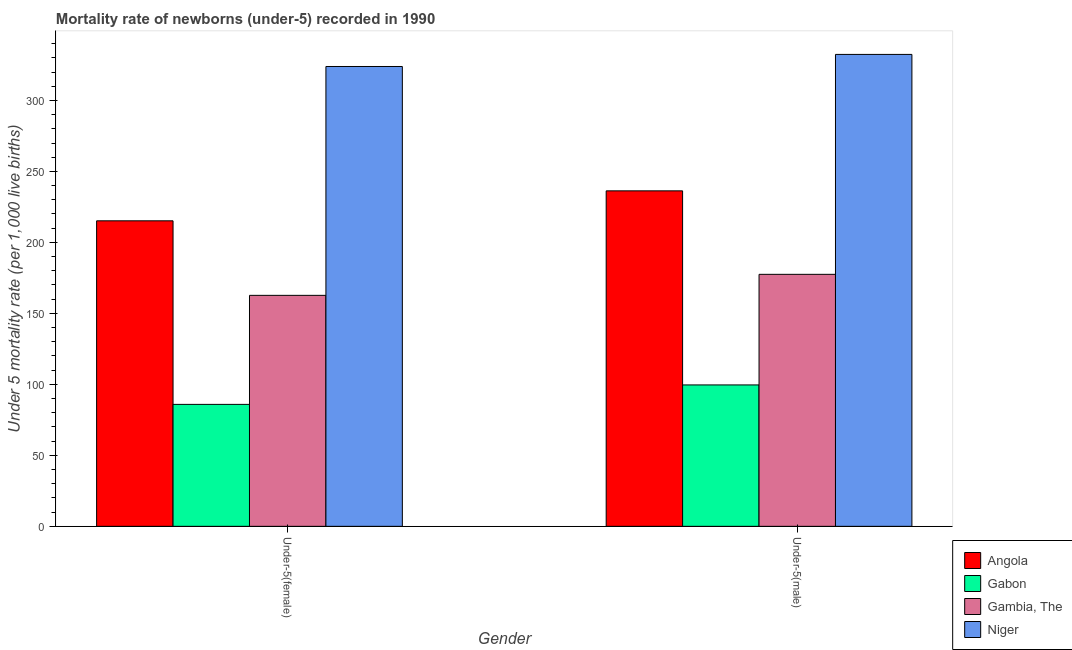How many different coloured bars are there?
Offer a very short reply. 4. How many groups of bars are there?
Provide a short and direct response. 2. How many bars are there on the 1st tick from the left?
Provide a succinct answer. 4. How many bars are there on the 1st tick from the right?
Ensure brevity in your answer.  4. What is the label of the 2nd group of bars from the left?
Make the answer very short. Under-5(male). What is the under-5 male mortality rate in Niger?
Make the answer very short. 332.4. Across all countries, what is the maximum under-5 female mortality rate?
Your response must be concise. 323.9. Across all countries, what is the minimum under-5 female mortality rate?
Ensure brevity in your answer.  85.9. In which country was the under-5 male mortality rate maximum?
Give a very brief answer. Niger. In which country was the under-5 female mortality rate minimum?
Provide a succinct answer. Gabon. What is the total under-5 male mortality rate in the graph?
Keep it short and to the point. 845.8. What is the difference between the under-5 male mortality rate in Gambia, The and that in Gabon?
Ensure brevity in your answer.  77.9. What is the difference between the under-5 female mortality rate in Angola and the under-5 male mortality rate in Gambia, The?
Give a very brief answer. 37.7. What is the average under-5 male mortality rate per country?
Your answer should be very brief. 211.45. What is the difference between the under-5 male mortality rate and under-5 female mortality rate in Gambia, The?
Provide a succinct answer. 14.8. In how many countries, is the under-5 female mortality rate greater than 10 ?
Make the answer very short. 4. What is the ratio of the under-5 male mortality rate in Gabon to that in Angola?
Make the answer very short. 0.42. Is the under-5 male mortality rate in Niger less than that in Angola?
Ensure brevity in your answer.  No. In how many countries, is the under-5 female mortality rate greater than the average under-5 female mortality rate taken over all countries?
Offer a terse response. 2. What does the 3rd bar from the left in Under-5(female) represents?
Your answer should be compact. Gambia, The. What does the 4th bar from the right in Under-5(female) represents?
Give a very brief answer. Angola. How many bars are there?
Your answer should be very brief. 8. How many countries are there in the graph?
Keep it short and to the point. 4. What is the difference between two consecutive major ticks on the Y-axis?
Your answer should be very brief. 50. Are the values on the major ticks of Y-axis written in scientific E-notation?
Provide a succinct answer. No. Does the graph contain grids?
Provide a short and direct response. No. Where does the legend appear in the graph?
Ensure brevity in your answer.  Bottom right. How many legend labels are there?
Your answer should be compact. 4. How are the legend labels stacked?
Offer a terse response. Vertical. What is the title of the graph?
Offer a terse response. Mortality rate of newborns (under-5) recorded in 1990. What is the label or title of the Y-axis?
Offer a very short reply. Under 5 mortality rate (per 1,0 live births). What is the Under 5 mortality rate (per 1,000 live births) of Angola in Under-5(female)?
Your answer should be compact. 215.2. What is the Under 5 mortality rate (per 1,000 live births) of Gabon in Under-5(female)?
Offer a very short reply. 85.9. What is the Under 5 mortality rate (per 1,000 live births) in Gambia, The in Under-5(female)?
Keep it short and to the point. 162.7. What is the Under 5 mortality rate (per 1,000 live births) in Niger in Under-5(female)?
Offer a very short reply. 323.9. What is the Under 5 mortality rate (per 1,000 live births) in Angola in Under-5(male)?
Give a very brief answer. 236.3. What is the Under 5 mortality rate (per 1,000 live births) in Gabon in Under-5(male)?
Offer a very short reply. 99.6. What is the Under 5 mortality rate (per 1,000 live births) in Gambia, The in Under-5(male)?
Ensure brevity in your answer.  177.5. What is the Under 5 mortality rate (per 1,000 live births) of Niger in Under-5(male)?
Offer a very short reply. 332.4. Across all Gender, what is the maximum Under 5 mortality rate (per 1,000 live births) in Angola?
Your answer should be compact. 236.3. Across all Gender, what is the maximum Under 5 mortality rate (per 1,000 live births) in Gabon?
Ensure brevity in your answer.  99.6. Across all Gender, what is the maximum Under 5 mortality rate (per 1,000 live births) of Gambia, The?
Provide a short and direct response. 177.5. Across all Gender, what is the maximum Under 5 mortality rate (per 1,000 live births) of Niger?
Give a very brief answer. 332.4. Across all Gender, what is the minimum Under 5 mortality rate (per 1,000 live births) in Angola?
Offer a terse response. 215.2. Across all Gender, what is the minimum Under 5 mortality rate (per 1,000 live births) of Gabon?
Give a very brief answer. 85.9. Across all Gender, what is the minimum Under 5 mortality rate (per 1,000 live births) of Gambia, The?
Give a very brief answer. 162.7. Across all Gender, what is the minimum Under 5 mortality rate (per 1,000 live births) of Niger?
Your answer should be very brief. 323.9. What is the total Under 5 mortality rate (per 1,000 live births) of Angola in the graph?
Your response must be concise. 451.5. What is the total Under 5 mortality rate (per 1,000 live births) of Gabon in the graph?
Keep it short and to the point. 185.5. What is the total Under 5 mortality rate (per 1,000 live births) in Gambia, The in the graph?
Your response must be concise. 340.2. What is the total Under 5 mortality rate (per 1,000 live births) in Niger in the graph?
Make the answer very short. 656.3. What is the difference between the Under 5 mortality rate (per 1,000 live births) in Angola in Under-5(female) and that in Under-5(male)?
Provide a short and direct response. -21.1. What is the difference between the Under 5 mortality rate (per 1,000 live births) of Gabon in Under-5(female) and that in Under-5(male)?
Your response must be concise. -13.7. What is the difference between the Under 5 mortality rate (per 1,000 live births) in Gambia, The in Under-5(female) and that in Under-5(male)?
Your answer should be compact. -14.8. What is the difference between the Under 5 mortality rate (per 1,000 live births) of Niger in Under-5(female) and that in Under-5(male)?
Your answer should be compact. -8.5. What is the difference between the Under 5 mortality rate (per 1,000 live births) of Angola in Under-5(female) and the Under 5 mortality rate (per 1,000 live births) of Gabon in Under-5(male)?
Offer a terse response. 115.6. What is the difference between the Under 5 mortality rate (per 1,000 live births) in Angola in Under-5(female) and the Under 5 mortality rate (per 1,000 live births) in Gambia, The in Under-5(male)?
Give a very brief answer. 37.7. What is the difference between the Under 5 mortality rate (per 1,000 live births) of Angola in Under-5(female) and the Under 5 mortality rate (per 1,000 live births) of Niger in Under-5(male)?
Keep it short and to the point. -117.2. What is the difference between the Under 5 mortality rate (per 1,000 live births) of Gabon in Under-5(female) and the Under 5 mortality rate (per 1,000 live births) of Gambia, The in Under-5(male)?
Give a very brief answer. -91.6. What is the difference between the Under 5 mortality rate (per 1,000 live births) of Gabon in Under-5(female) and the Under 5 mortality rate (per 1,000 live births) of Niger in Under-5(male)?
Give a very brief answer. -246.5. What is the difference between the Under 5 mortality rate (per 1,000 live births) of Gambia, The in Under-5(female) and the Under 5 mortality rate (per 1,000 live births) of Niger in Under-5(male)?
Provide a succinct answer. -169.7. What is the average Under 5 mortality rate (per 1,000 live births) of Angola per Gender?
Make the answer very short. 225.75. What is the average Under 5 mortality rate (per 1,000 live births) in Gabon per Gender?
Provide a short and direct response. 92.75. What is the average Under 5 mortality rate (per 1,000 live births) of Gambia, The per Gender?
Offer a very short reply. 170.1. What is the average Under 5 mortality rate (per 1,000 live births) in Niger per Gender?
Offer a very short reply. 328.15. What is the difference between the Under 5 mortality rate (per 1,000 live births) of Angola and Under 5 mortality rate (per 1,000 live births) of Gabon in Under-5(female)?
Make the answer very short. 129.3. What is the difference between the Under 5 mortality rate (per 1,000 live births) of Angola and Under 5 mortality rate (per 1,000 live births) of Gambia, The in Under-5(female)?
Offer a terse response. 52.5. What is the difference between the Under 5 mortality rate (per 1,000 live births) of Angola and Under 5 mortality rate (per 1,000 live births) of Niger in Under-5(female)?
Your answer should be very brief. -108.7. What is the difference between the Under 5 mortality rate (per 1,000 live births) of Gabon and Under 5 mortality rate (per 1,000 live births) of Gambia, The in Under-5(female)?
Your answer should be compact. -76.8. What is the difference between the Under 5 mortality rate (per 1,000 live births) of Gabon and Under 5 mortality rate (per 1,000 live births) of Niger in Under-5(female)?
Your answer should be very brief. -238. What is the difference between the Under 5 mortality rate (per 1,000 live births) of Gambia, The and Under 5 mortality rate (per 1,000 live births) of Niger in Under-5(female)?
Keep it short and to the point. -161.2. What is the difference between the Under 5 mortality rate (per 1,000 live births) in Angola and Under 5 mortality rate (per 1,000 live births) in Gabon in Under-5(male)?
Offer a terse response. 136.7. What is the difference between the Under 5 mortality rate (per 1,000 live births) in Angola and Under 5 mortality rate (per 1,000 live births) in Gambia, The in Under-5(male)?
Give a very brief answer. 58.8. What is the difference between the Under 5 mortality rate (per 1,000 live births) of Angola and Under 5 mortality rate (per 1,000 live births) of Niger in Under-5(male)?
Offer a very short reply. -96.1. What is the difference between the Under 5 mortality rate (per 1,000 live births) of Gabon and Under 5 mortality rate (per 1,000 live births) of Gambia, The in Under-5(male)?
Offer a terse response. -77.9. What is the difference between the Under 5 mortality rate (per 1,000 live births) of Gabon and Under 5 mortality rate (per 1,000 live births) of Niger in Under-5(male)?
Offer a very short reply. -232.8. What is the difference between the Under 5 mortality rate (per 1,000 live births) of Gambia, The and Under 5 mortality rate (per 1,000 live births) of Niger in Under-5(male)?
Give a very brief answer. -154.9. What is the ratio of the Under 5 mortality rate (per 1,000 live births) of Angola in Under-5(female) to that in Under-5(male)?
Provide a short and direct response. 0.91. What is the ratio of the Under 5 mortality rate (per 1,000 live births) in Gabon in Under-5(female) to that in Under-5(male)?
Your answer should be very brief. 0.86. What is the ratio of the Under 5 mortality rate (per 1,000 live births) in Gambia, The in Under-5(female) to that in Under-5(male)?
Provide a short and direct response. 0.92. What is the ratio of the Under 5 mortality rate (per 1,000 live births) of Niger in Under-5(female) to that in Under-5(male)?
Give a very brief answer. 0.97. What is the difference between the highest and the second highest Under 5 mortality rate (per 1,000 live births) in Angola?
Make the answer very short. 21.1. What is the difference between the highest and the second highest Under 5 mortality rate (per 1,000 live births) in Niger?
Offer a terse response. 8.5. What is the difference between the highest and the lowest Under 5 mortality rate (per 1,000 live births) in Angola?
Your response must be concise. 21.1. What is the difference between the highest and the lowest Under 5 mortality rate (per 1,000 live births) of Gambia, The?
Provide a short and direct response. 14.8. What is the difference between the highest and the lowest Under 5 mortality rate (per 1,000 live births) in Niger?
Provide a short and direct response. 8.5. 